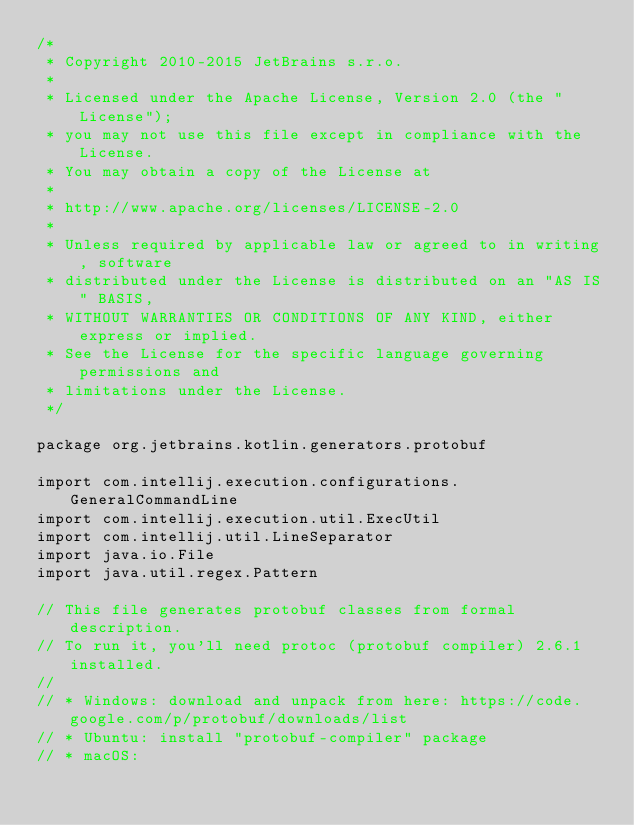Convert code to text. <code><loc_0><loc_0><loc_500><loc_500><_Kotlin_>/*
 * Copyright 2010-2015 JetBrains s.r.o.
 *
 * Licensed under the Apache License, Version 2.0 (the "License");
 * you may not use this file except in compliance with the License.
 * You may obtain a copy of the License at
 *
 * http://www.apache.org/licenses/LICENSE-2.0
 *
 * Unless required by applicable law or agreed to in writing, software
 * distributed under the License is distributed on an "AS IS" BASIS,
 * WITHOUT WARRANTIES OR CONDITIONS OF ANY KIND, either express or implied.
 * See the License for the specific language governing permissions and
 * limitations under the License.
 */

package org.jetbrains.kotlin.generators.protobuf

import com.intellij.execution.configurations.GeneralCommandLine
import com.intellij.execution.util.ExecUtil
import com.intellij.util.LineSeparator
import java.io.File
import java.util.regex.Pattern

// This file generates protobuf classes from formal description.
// To run it, you'll need protoc (protobuf compiler) 2.6.1 installed.
//
// * Windows: download and unpack from here: https://code.google.com/p/protobuf/downloads/list
// * Ubuntu: install "protobuf-compiler" package
// * macOS:</code> 